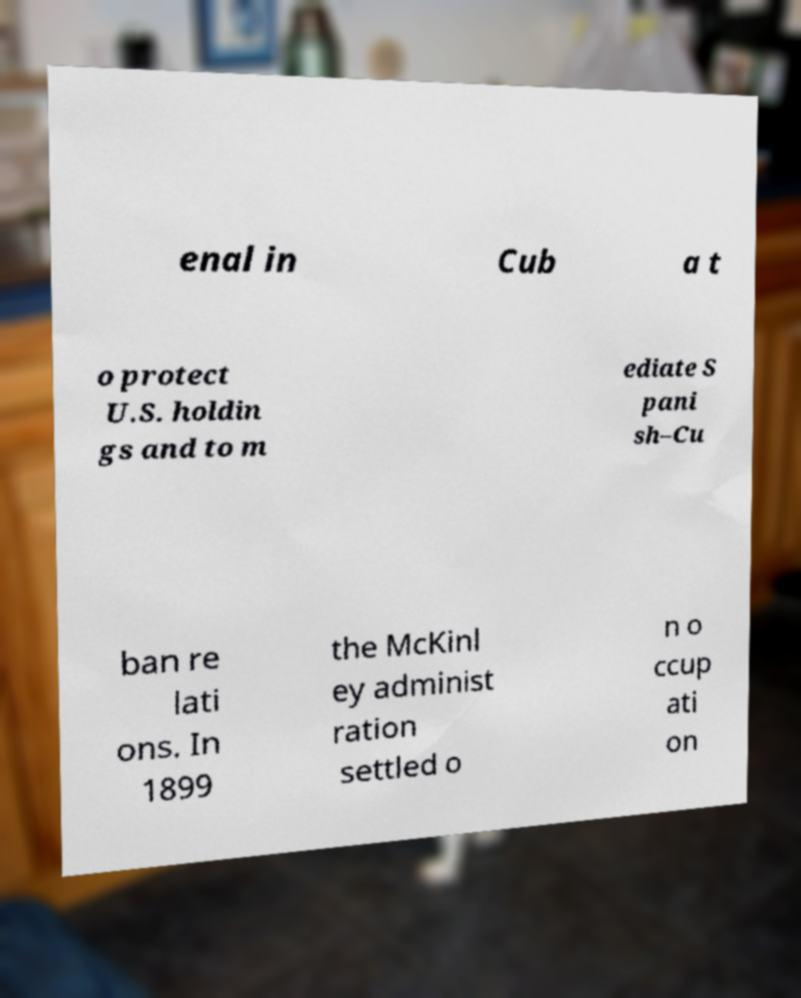Could you assist in decoding the text presented in this image and type it out clearly? enal in Cub a t o protect U.S. holdin gs and to m ediate S pani sh–Cu ban re lati ons. In 1899 the McKinl ey administ ration settled o n o ccup ati on 